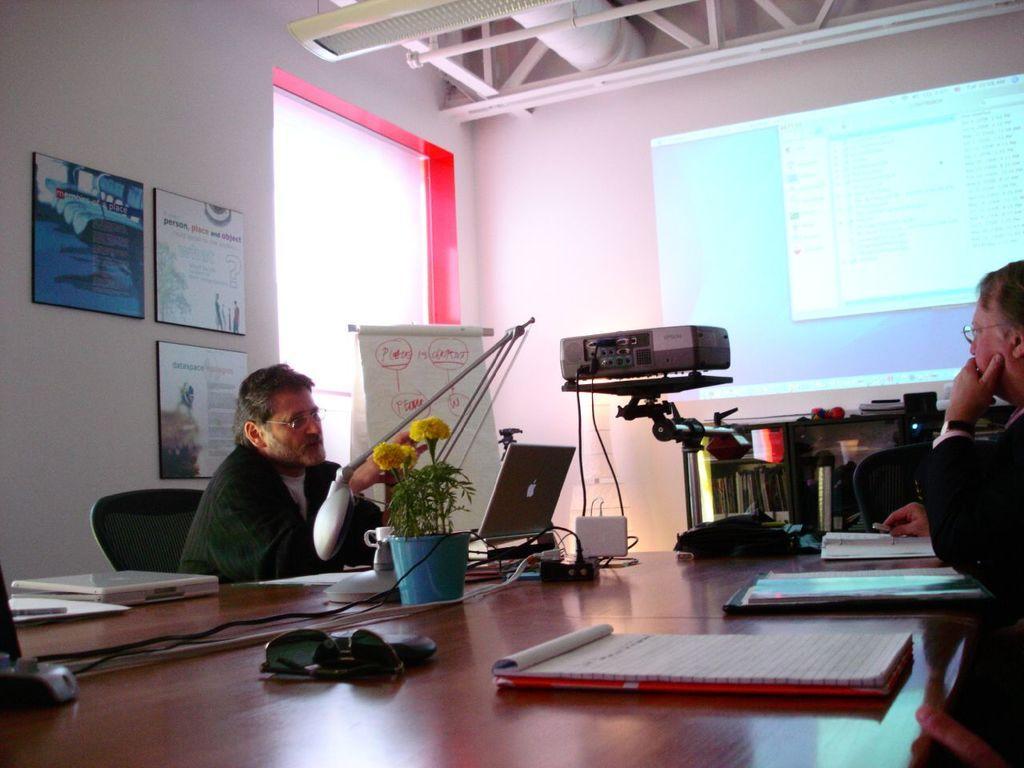Could you give a brief overview of what you see in this image? In this picture there are two men sitting in the room and discussing something. In the front there is a table with the laptop and projector lamp. Behind there is a white color roller banner and a wall with three photo frame hanging on it. On the straight wall there is a projector screen and above we can see the air conditioner pipes and a metal frame. 